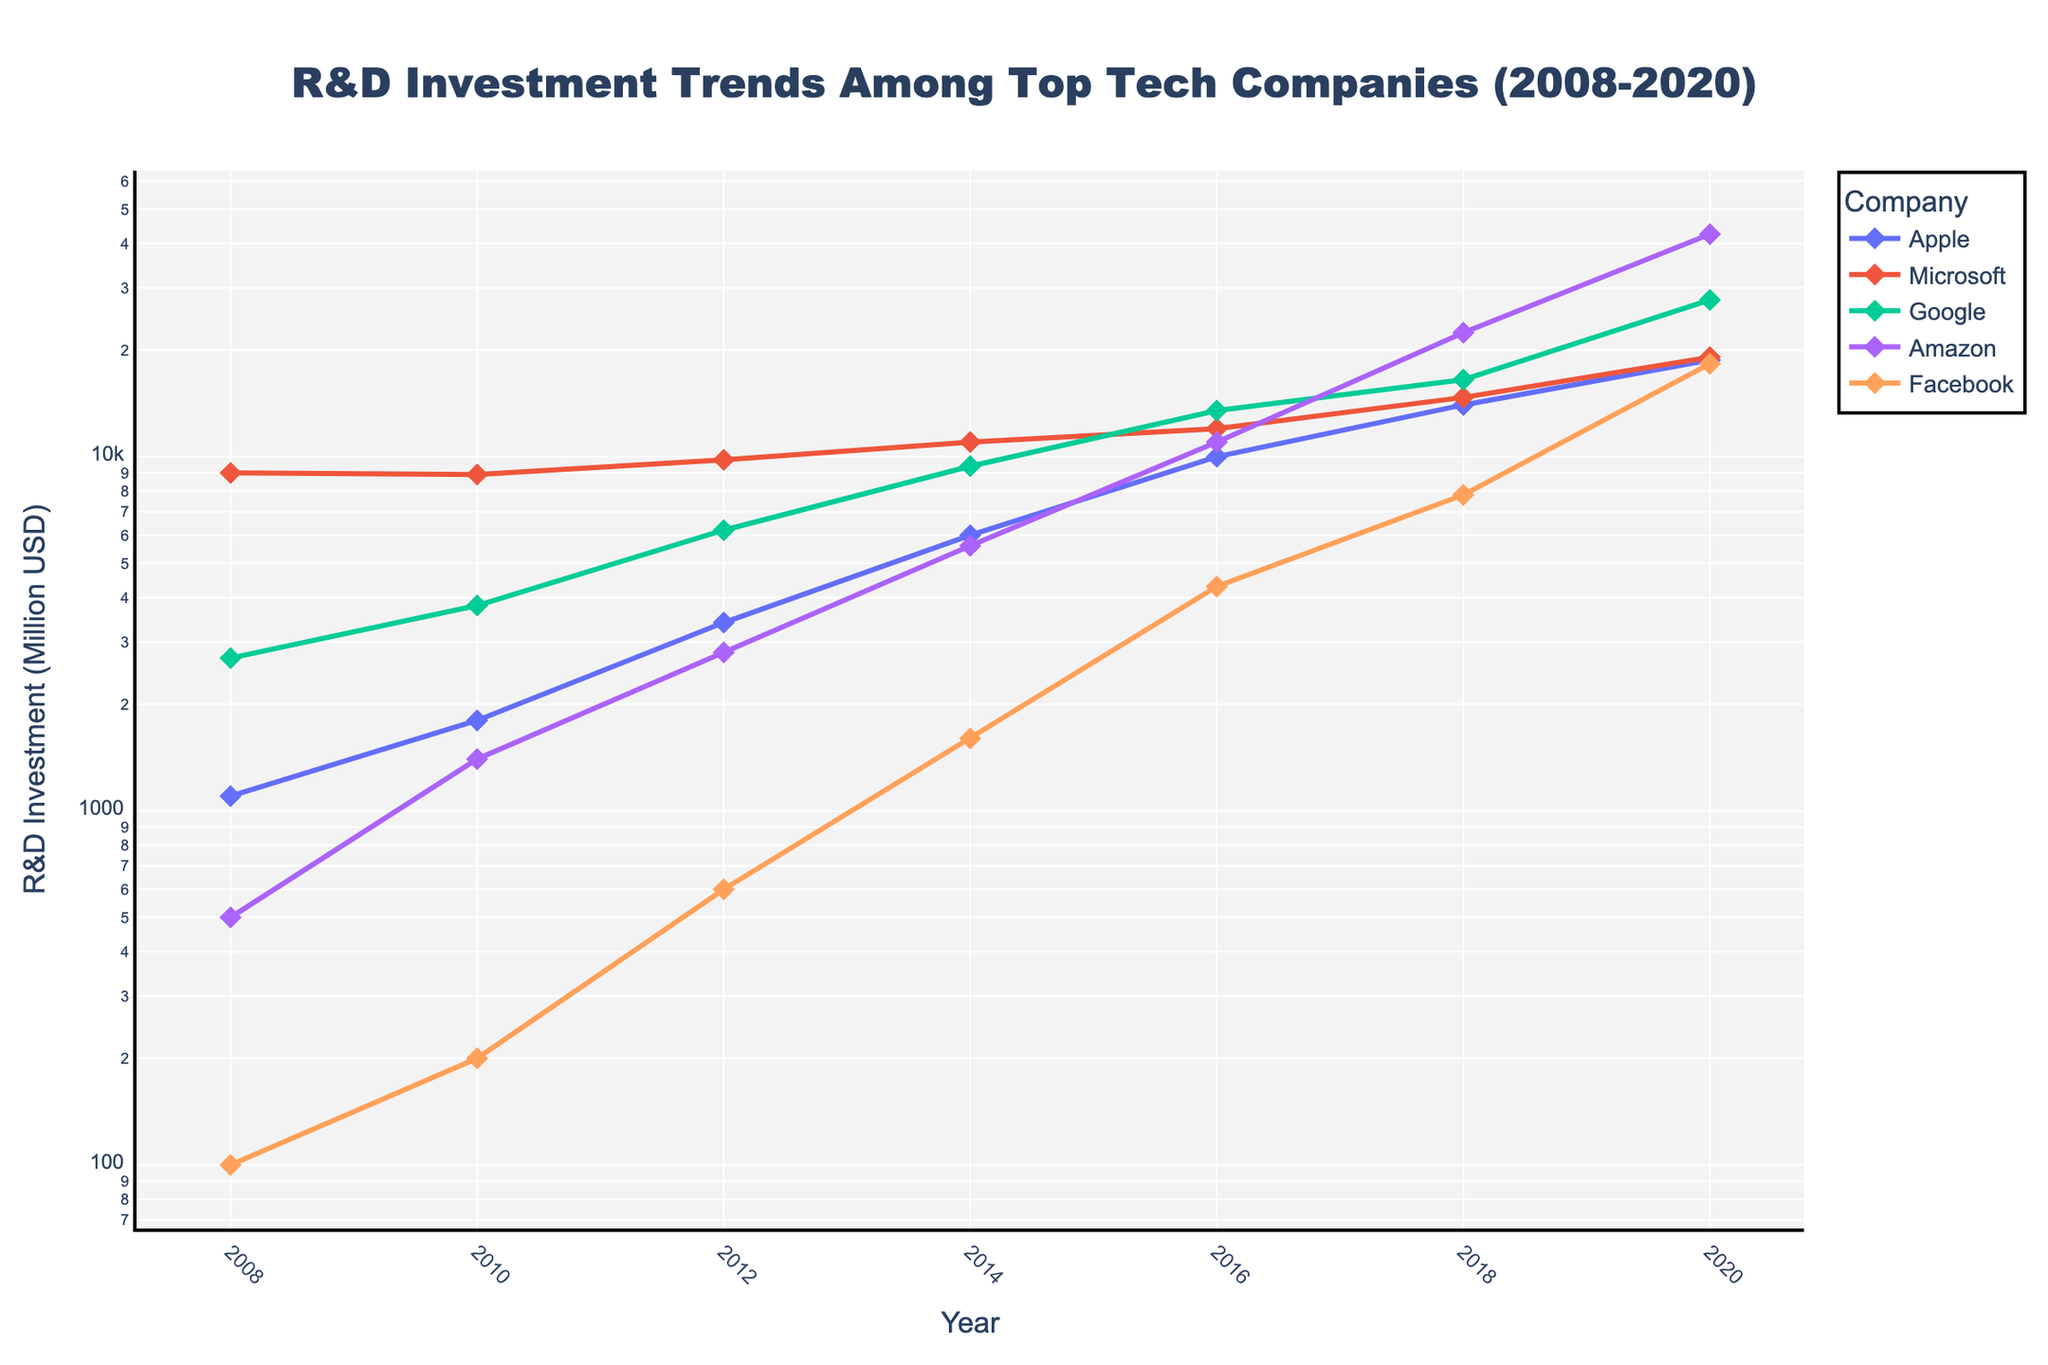What's the title of the figure? The title is prominently displayed at the top of the figure, stating the main subject addressed by the visualization.
Answer: R&D Investment Trends Among Top Tech Companies (2008-2020) Which company had the highest R&D investment in 2020? From the data points in 2020 on the log-scale y-axis, Amazon shows the highest value among all the companies listed.
Answer: Amazon How does Apple's 2010 R&D investment compare to its 2020 investment? By examining Apple's data points for 2010 and 2020 on the log-scale y-axis, we see that the 2020 investment is significantly higher than that of 2010. Apple's R&D investment increased from around 1800 million USD in 2010 to 18750 million USD in 2020.
Answer: Much higher in 2020 What is the trend of Microsoft's R&D investment from 2008 to 2020? To determine the trend, observe the connected data points for Microsoft over the years. The line shows a steady increase overall, indicating an upward trend in R&D investment.
Answer: Upward trend Between Google and Apple, which company had a higher R&D investment in 2014? Compare the data points for Google and Apple in 2014. On the log-scale y-axis, Apple's R&D investment is higher than Google's.
Answer: Apple What is the difference in R&D investment between Facebook and Amazon in 2020? Look at the data points for Facebook and Amazon in 2020 and calculate the difference. Amazon has 42500 million USD, and Facebook has 18300 million USD. The difference is 42500 - 18300 = 24200 million USD.
Answer: 24200 million USD How many companies had an R&D investment below 1000 million USD in 2008? Evaluate the 2008 data points for each company, observing which ones lie below the 1000 million USD mark on the log-scale y-axis. Only Facebook, with an investment of 100 million USD, falls below this threshold.
Answer: One Which company exhibited the most substantial increase in R&D investment between any two consecutive years? By examining the steepness between consecutive data points for each company, Amazon shows the most substantial increase between 2018 (22400 million USD) and 2020 (42500 million USD).
Answer: Amazon What is the R&D investment growth factor for Facebook from 2008 to 2020? The growth factor is calculated by dividing the 2020 value by the 2008 value. For Facebook, it is 18300 million USD (2020) divided by 100 million USD (2008), resulting in a growth factor of 18300 / 100 = 183.
Answer: 183 What general pattern can be inferred from the log-scaled y-axis regarding the company's R&D investments over time? A log scale helps in discerning exponential growth. The consistent upward trend lines for all companies imply that their R&D investments have generally grown exponentially over the years.
Answer: Exponential growth 